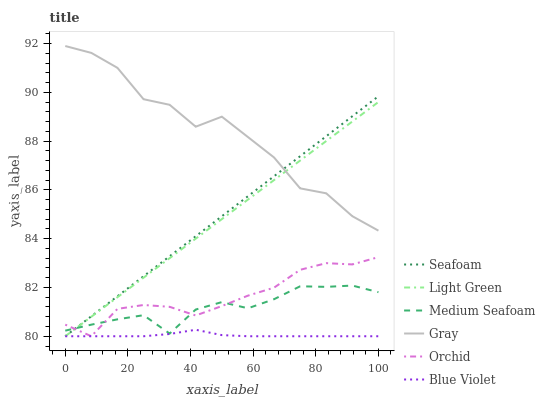Does Seafoam have the minimum area under the curve?
Answer yes or no. No. Does Seafoam have the maximum area under the curve?
Answer yes or no. No. Is Light Green the smoothest?
Answer yes or no. No. Is Light Green the roughest?
Answer yes or no. No. Does Medium Seafoam have the lowest value?
Answer yes or no. No. Does Seafoam have the highest value?
Answer yes or no. No. Is Medium Seafoam less than Gray?
Answer yes or no. Yes. Is Gray greater than Medium Seafoam?
Answer yes or no. Yes. Does Medium Seafoam intersect Gray?
Answer yes or no. No. 